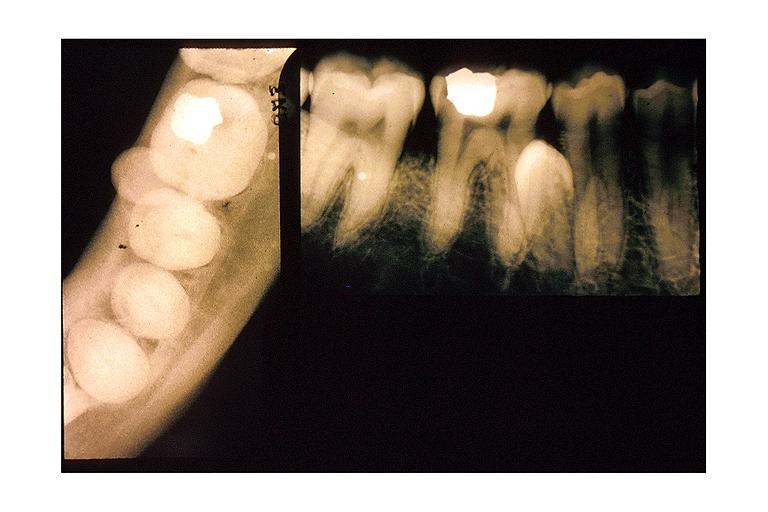does this image show impacted supernumerary tooth?
Answer the question using a single word or phrase. Yes 